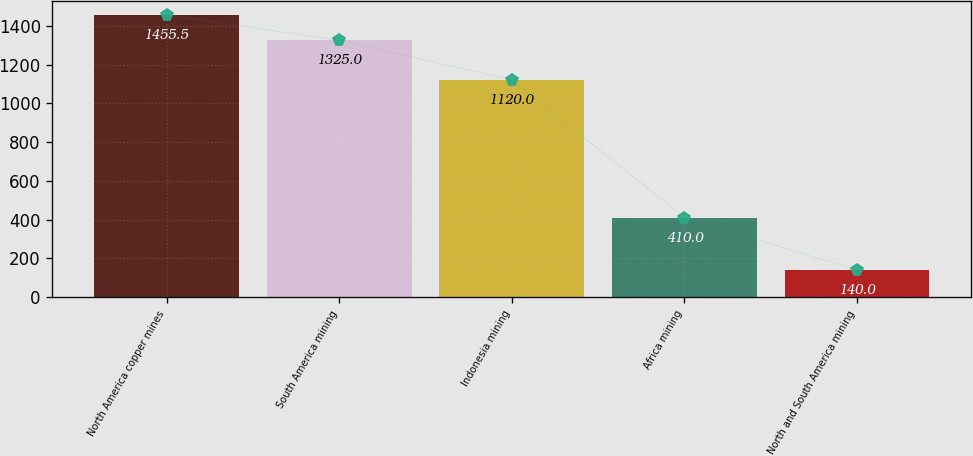Convert chart. <chart><loc_0><loc_0><loc_500><loc_500><bar_chart><fcel>North America copper mines<fcel>South America mining<fcel>Indonesia mining<fcel>Africa mining<fcel>North and South America mining<nl><fcel>1455.5<fcel>1325<fcel>1120<fcel>410<fcel>140<nl></chart> 